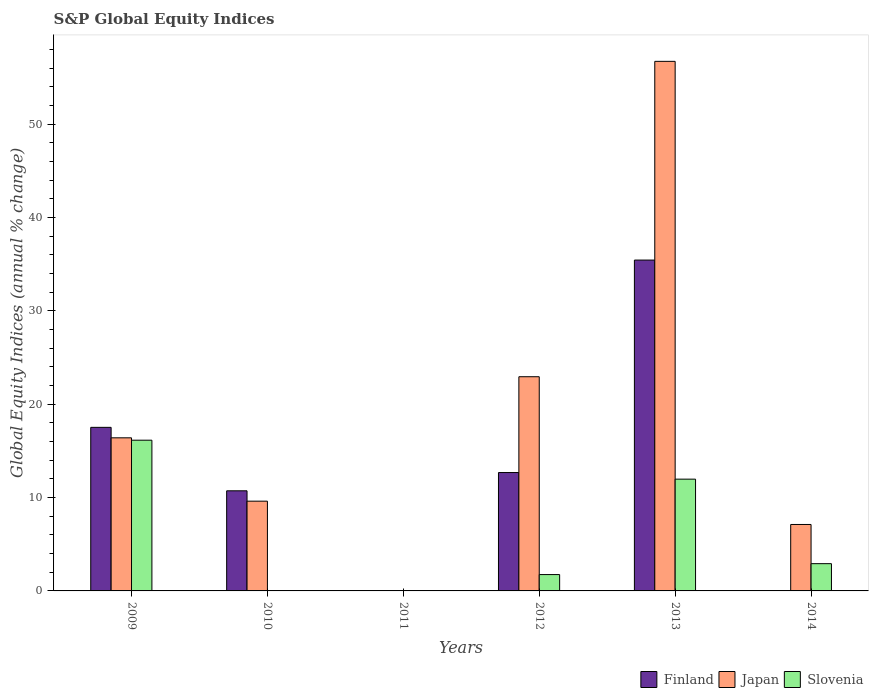Are the number of bars per tick equal to the number of legend labels?
Make the answer very short. No. How many bars are there on the 5th tick from the left?
Offer a very short reply. 3. What is the label of the 3rd group of bars from the left?
Keep it short and to the point. 2011. In how many cases, is the number of bars for a given year not equal to the number of legend labels?
Provide a succinct answer. 3. What is the global equity indices in Finland in 2013?
Provide a short and direct response. 35.44. Across all years, what is the maximum global equity indices in Slovenia?
Your answer should be compact. 16.14. Across all years, what is the minimum global equity indices in Finland?
Your response must be concise. 0. In which year was the global equity indices in Finland maximum?
Your answer should be compact. 2013. What is the total global equity indices in Slovenia in the graph?
Offer a very short reply. 32.79. What is the difference between the global equity indices in Slovenia in 2012 and that in 2014?
Provide a short and direct response. -1.17. What is the difference between the global equity indices in Japan in 2010 and the global equity indices in Finland in 2012?
Your answer should be compact. -3.06. What is the average global equity indices in Finland per year?
Offer a very short reply. 12.73. In the year 2012, what is the difference between the global equity indices in Japan and global equity indices in Slovenia?
Keep it short and to the point. 21.19. What is the ratio of the global equity indices in Slovenia in 2012 to that in 2014?
Give a very brief answer. 0.6. Is the difference between the global equity indices in Japan in 2009 and 2012 greater than the difference between the global equity indices in Slovenia in 2009 and 2012?
Provide a short and direct response. No. What is the difference between the highest and the second highest global equity indices in Slovenia?
Keep it short and to the point. 4.17. What is the difference between the highest and the lowest global equity indices in Finland?
Ensure brevity in your answer.  35.44. How many bars are there?
Ensure brevity in your answer.  13. Are all the bars in the graph horizontal?
Your response must be concise. No. How many years are there in the graph?
Your answer should be compact. 6. Are the values on the major ticks of Y-axis written in scientific E-notation?
Keep it short and to the point. No. Does the graph contain grids?
Provide a short and direct response. No. How many legend labels are there?
Your answer should be compact. 3. How are the legend labels stacked?
Offer a terse response. Horizontal. What is the title of the graph?
Your response must be concise. S&P Global Equity Indices. What is the label or title of the Y-axis?
Your answer should be compact. Global Equity Indices (annual % change). What is the Global Equity Indices (annual % change) of Finland in 2009?
Provide a succinct answer. 17.52. What is the Global Equity Indices (annual % change) in Japan in 2009?
Provide a succinct answer. 16.4. What is the Global Equity Indices (annual % change) in Slovenia in 2009?
Your answer should be very brief. 16.14. What is the Global Equity Indices (annual % change) of Finland in 2010?
Your answer should be compact. 10.72. What is the Global Equity Indices (annual % change) of Japan in 2010?
Provide a short and direct response. 9.61. What is the Global Equity Indices (annual % change) of Slovenia in 2010?
Keep it short and to the point. 0. What is the Global Equity Indices (annual % change) in Finland in 2011?
Your response must be concise. 0. What is the Global Equity Indices (annual % change) of Japan in 2011?
Make the answer very short. 0. What is the Global Equity Indices (annual % change) of Slovenia in 2011?
Your answer should be very brief. 0. What is the Global Equity Indices (annual % change) of Finland in 2012?
Offer a terse response. 12.68. What is the Global Equity Indices (annual % change) in Japan in 2012?
Your answer should be very brief. 22.94. What is the Global Equity Indices (annual % change) of Slovenia in 2012?
Make the answer very short. 1.75. What is the Global Equity Indices (annual % change) of Finland in 2013?
Give a very brief answer. 35.44. What is the Global Equity Indices (annual % change) of Japan in 2013?
Provide a succinct answer. 56.72. What is the Global Equity Indices (annual % change) of Slovenia in 2013?
Give a very brief answer. 11.97. What is the Global Equity Indices (annual % change) in Finland in 2014?
Provide a succinct answer. 0. What is the Global Equity Indices (annual % change) of Japan in 2014?
Provide a succinct answer. 7.12. What is the Global Equity Indices (annual % change) in Slovenia in 2014?
Your answer should be very brief. 2.92. Across all years, what is the maximum Global Equity Indices (annual % change) in Finland?
Keep it short and to the point. 35.44. Across all years, what is the maximum Global Equity Indices (annual % change) in Japan?
Your response must be concise. 56.72. Across all years, what is the maximum Global Equity Indices (annual % change) in Slovenia?
Your answer should be very brief. 16.14. Across all years, what is the minimum Global Equity Indices (annual % change) in Finland?
Make the answer very short. 0. What is the total Global Equity Indices (annual % change) of Finland in the graph?
Your answer should be very brief. 76.36. What is the total Global Equity Indices (annual % change) of Japan in the graph?
Keep it short and to the point. 112.79. What is the total Global Equity Indices (annual % change) in Slovenia in the graph?
Provide a succinct answer. 32.79. What is the difference between the Global Equity Indices (annual % change) of Finland in 2009 and that in 2010?
Give a very brief answer. 6.8. What is the difference between the Global Equity Indices (annual % change) in Japan in 2009 and that in 2010?
Make the answer very short. 6.78. What is the difference between the Global Equity Indices (annual % change) of Finland in 2009 and that in 2012?
Ensure brevity in your answer.  4.84. What is the difference between the Global Equity Indices (annual % change) in Japan in 2009 and that in 2012?
Make the answer very short. -6.54. What is the difference between the Global Equity Indices (annual % change) of Slovenia in 2009 and that in 2012?
Your response must be concise. 14.39. What is the difference between the Global Equity Indices (annual % change) in Finland in 2009 and that in 2013?
Your response must be concise. -17.92. What is the difference between the Global Equity Indices (annual % change) of Japan in 2009 and that in 2013?
Make the answer very short. -40.32. What is the difference between the Global Equity Indices (annual % change) in Slovenia in 2009 and that in 2013?
Offer a terse response. 4.17. What is the difference between the Global Equity Indices (annual % change) of Japan in 2009 and that in 2014?
Offer a terse response. 9.28. What is the difference between the Global Equity Indices (annual % change) of Slovenia in 2009 and that in 2014?
Your answer should be compact. 13.22. What is the difference between the Global Equity Indices (annual % change) of Finland in 2010 and that in 2012?
Make the answer very short. -1.96. What is the difference between the Global Equity Indices (annual % change) of Japan in 2010 and that in 2012?
Give a very brief answer. -13.33. What is the difference between the Global Equity Indices (annual % change) of Finland in 2010 and that in 2013?
Offer a terse response. -24.71. What is the difference between the Global Equity Indices (annual % change) in Japan in 2010 and that in 2013?
Your answer should be compact. -47.11. What is the difference between the Global Equity Indices (annual % change) in Japan in 2010 and that in 2014?
Give a very brief answer. 2.5. What is the difference between the Global Equity Indices (annual % change) of Finland in 2012 and that in 2013?
Give a very brief answer. -22.76. What is the difference between the Global Equity Indices (annual % change) in Japan in 2012 and that in 2013?
Ensure brevity in your answer.  -33.78. What is the difference between the Global Equity Indices (annual % change) of Slovenia in 2012 and that in 2013?
Ensure brevity in your answer.  -10.22. What is the difference between the Global Equity Indices (annual % change) of Japan in 2012 and that in 2014?
Offer a terse response. 15.82. What is the difference between the Global Equity Indices (annual % change) of Slovenia in 2012 and that in 2014?
Offer a terse response. -1.17. What is the difference between the Global Equity Indices (annual % change) in Japan in 2013 and that in 2014?
Provide a short and direct response. 49.6. What is the difference between the Global Equity Indices (annual % change) of Slovenia in 2013 and that in 2014?
Offer a terse response. 9.05. What is the difference between the Global Equity Indices (annual % change) in Finland in 2009 and the Global Equity Indices (annual % change) in Japan in 2010?
Make the answer very short. 7.91. What is the difference between the Global Equity Indices (annual % change) in Finland in 2009 and the Global Equity Indices (annual % change) in Japan in 2012?
Ensure brevity in your answer.  -5.42. What is the difference between the Global Equity Indices (annual % change) of Finland in 2009 and the Global Equity Indices (annual % change) of Slovenia in 2012?
Offer a terse response. 15.77. What is the difference between the Global Equity Indices (annual % change) in Japan in 2009 and the Global Equity Indices (annual % change) in Slovenia in 2012?
Keep it short and to the point. 14.65. What is the difference between the Global Equity Indices (annual % change) in Finland in 2009 and the Global Equity Indices (annual % change) in Japan in 2013?
Ensure brevity in your answer.  -39.2. What is the difference between the Global Equity Indices (annual % change) in Finland in 2009 and the Global Equity Indices (annual % change) in Slovenia in 2013?
Keep it short and to the point. 5.55. What is the difference between the Global Equity Indices (annual % change) of Japan in 2009 and the Global Equity Indices (annual % change) of Slovenia in 2013?
Make the answer very short. 4.43. What is the difference between the Global Equity Indices (annual % change) in Finland in 2009 and the Global Equity Indices (annual % change) in Japan in 2014?
Provide a succinct answer. 10.4. What is the difference between the Global Equity Indices (annual % change) of Finland in 2009 and the Global Equity Indices (annual % change) of Slovenia in 2014?
Your answer should be very brief. 14.6. What is the difference between the Global Equity Indices (annual % change) in Japan in 2009 and the Global Equity Indices (annual % change) in Slovenia in 2014?
Ensure brevity in your answer.  13.48. What is the difference between the Global Equity Indices (annual % change) of Finland in 2010 and the Global Equity Indices (annual % change) of Japan in 2012?
Your answer should be compact. -12.22. What is the difference between the Global Equity Indices (annual % change) in Finland in 2010 and the Global Equity Indices (annual % change) in Slovenia in 2012?
Make the answer very short. 8.97. What is the difference between the Global Equity Indices (annual % change) of Japan in 2010 and the Global Equity Indices (annual % change) of Slovenia in 2012?
Ensure brevity in your answer.  7.86. What is the difference between the Global Equity Indices (annual % change) of Finland in 2010 and the Global Equity Indices (annual % change) of Japan in 2013?
Your answer should be very brief. -46. What is the difference between the Global Equity Indices (annual % change) in Finland in 2010 and the Global Equity Indices (annual % change) in Slovenia in 2013?
Provide a succinct answer. -1.25. What is the difference between the Global Equity Indices (annual % change) of Japan in 2010 and the Global Equity Indices (annual % change) of Slovenia in 2013?
Offer a terse response. -2.36. What is the difference between the Global Equity Indices (annual % change) in Finland in 2010 and the Global Equity Indices (annual % change) in Japan in 2014?
Ensure brevity in your answer.  3.61. What is the difference between the Global Equity Indices (annual % change) in Finland in 2010 and the Global Equity Indices (annual % change) in Slovenia in 2014?
Keep it short and to the point. 7.8. What is the difference between the Global Equity Indices (annual % change) of Japan in 2010 and the Global Equity Indices (annual % change) of Slovenia in 2014?
Offer a very short reply. 6.7. What is the difference between the Global Equity Indices (annual % change) of Finland in 2012 and the Global Equity Indices (annual % change) of Japan in 2013?
Provide a short and direct response. -44.04. What is the difference between the Global Equity Indices (annual % change) of Finland in 2012 and the Global Equity Indices (annual % change) of Slovenia in 2013?
Make the answer very short. 0.71. What is the difference between the Global Equity Indices (annual % change) in Japan in 2012 and the Global Equity Indices (annual % change) in Slovenia in 2013?
Ensure brevity in your answer.  10.97. What is the difference between the Global Equity Indices (annual % change) in Finland in 2012 and the Global Equity Indices (annual % change) in Japan in 2014?
Make the answer very short. 5.56. What is the difference between the Global Equity Indices (annual % change) of Finland in 2012 and the Global Equity Indices (annual % change) of Slovenia in 2014?
Give a very brief answer. 9.76. What is the difference between the Global Equity Indices (annual % change) in Japan in 2012 and the Global Equity Indices (annual % change) in Slovenia in 2014?
Ensure brevity in your answer.  20.02. What is the difference between the Global Equity Indices (annual % change) in Finland in 2013 and the Global Equity Indices (annual % change) in Japan in 2014?
Your response must be concise. 28.32. What is the difference between the Global Equity Indices (annual % change) in Finland in 2013 and the Global Equity Indices (annual % change) in Slovenia in 2014?
Provide a short and direct response. 32.52. What is the difference between the Global Equity Indices (annual % change) in Japan in 2013 and the Global Equity Indices (annual % change) in Slovenia in 2014?
Your response must be concise. 53.8. What is the average Global Equity Indices (annual % change) of Finland per year?
Keep it short and to the point. 12.73. What is the average Global Equity Indices (annual % change) in Japan per year?
Ensure brevity in your answer.  18.8. What is the average Global Equity Indices (annual % change) of Slovenia per year?
Provide a short and direct response. 5.46. In the year 2009, what is the difference between the Global Equity Indices (annual % change) of Finland and Global Equity Indices (annual % change) of Japan?
Provide a succinct answer. 1.12. In the year 2009, what is the difference between the Global Equity Indices (annual % change) of Finland and Global Equity Indices (annual % change) of Slovenia?
Offer a very short reply. 1.38. In the year 2009, what is the difference between the Global Equity Indices (annual % change) in Japan and Global Equity Indices (annual % change) in Slovenia?
Offer a terse response. 0.26. In the year 2010, what is the difference between the Global Equity Indices (annual % change) in Finland and Global Equity Indices (annual % change) in Japan?
Keep it short and to the point. 1.11. In the year 2012, what is the difference between the Global Equity Indices (annual % change) of Finland and Global Equity Indices (annual % change) of Japan?
Provide a succinct answer. -10.26. In the year 2012, what is the difference between the Global Equity Indices (annual % change) in Finland and Global Equity Indices (annual % change) in Slovenia?
Your response must be concise. 10.93. In the year 2012, what is the difference between the Global Equity Indices (annual % change) in Japan and Global Equity Indices (annual % change) in Slovenia?
Your answer should be compact. 21.19. In the year 2013, what is the difference between the Global Equity Indices (annual % change) in Finland and Global Equity Indices (annual % change) in Japan?
Ensure brevity in your answer.  -21.28. In the year 2013, what is the difference between the Global Equity Indices (annual % change) of Finland and Global Equity Indices (annual % change) of Slovenia?
Provide a succinct answer. 23.46. In the year 2013, what is the difference between the Global Equity Indices (annual % change) in Japan and Global Equity Indices (annual % change) in Slovenia?
Offer a very short reply. 44.75. In the year 2014, what is the difference between the Global Equity Indices (annual % change) of Japan and Global Equity Indices (annual % change) of Slovenia?
Ensure brevity in your answer.  4.2. What is the ratio of the Global Equity Indices (annual % change) of Finland in 2009 to that in 2010?
Provide a short and direct response. 1.63. What is the ratio of the Global Equity Indices (annual % change) in Japan in 2009 to that in 2010?
Provide a short and direct response. 1.71. What is the ratio of the Global Equity Indices (annual % change) of Finland in 2009 to that in 2012?
Your answer should be compact. 1.38. What is the ratio of the Global Equity Indices (annual % change) in Japan in 2009 to that in 2012?
Your answer should be compact. 0.71. What is the ratio of the Global Equity Indices (annual % change) of Slovenia in 2009 to that in 2012?
Provide a short and direct response. 9.22. What is the ratio of the Global Equity Indices (annual % change) in Finland in 2009 to that in 2013?
Give a very brief answer. 0.49. What is the ratio of the Global Equity Indices (annual % change) in Japan in 2009 to that in 2013?
Provide a short and direct response. 0.29. What is the ratio of the Global Equity Indices (annual % change) in Slovenia in 2009 to that in 2013?
Your answer should be very brief. 1.35. What is the ratio of the Global Equity Indices (annual % change) of Japan in 2009 to that in 2014?
Make the answer very short. 2.3. What is the ratio of the Global Equity Indices (annual % change) of Slovenia in 2009 to that in 2014?
Offer a very short reply. 5.53. What is the ratio of the Global Equity Indices (annual % change) of Finland in 2010 to that in 2012?
Ensure brevity in your answer.  0.85. What is the ratio of the Global Equity Indices (annual % change) in Japan in 2010 to that in 2012?
Your response must be concise. 0.42. What is the ratio of the Global Equity Indices (annual % change) in Finland in 2010 to that in 2013?
Ensure brevity in your answer.  0.3. What is the ratio of the Global Equity Indices (annual % change) in Japan in 2010 to that in 2013?
Provide a succinct answer. 0.17. What is the ratio of the Global Equity Indices (annual % change) in Japan in 2010 to that in 2014?
Give a very brief answer. 1.35. What is the ratio of the Global Equity Indices (annual % change) of Finland in 2012 to that in 2013?
Offer a terse response. 0.36. What is the ratio of the Global Equity Indices (annual % change) in Japan in 2012 to that in 2013?
Offer a terse response. 0.4. What is the ratio of the Global Equity Indices (annual % change) in Slovenia in 2012 to that in 2013?
Offer a very short reply. 0.15. What is the ratio of the Global Equity Indices (annual % change) in Japan in 2012 to that in 2014?
Provide a succinct answer. 3.22. What is the ratio of the Global Equity Indices (annual % change) in Japan in 2013 to that in 2014?
Offer a very short reply. 7.97. What is the ratio of the Global Equity Indices (annual % change) in Slovenia in 2013 to that in 2014?
Make the answer very short. 4.1. What is the difference between the highest and the second highest Global Equity Indices (annual % change) of Finland?
Provide a succinct answer. 17.92. What is the difference between the highest and the second highest Global Equity Indices (annual % change) in Japan?
Your answer should be very brief. 33.78. What is the difference between the highest and the second highest Global Equity Indices (annual % change) in Slovenia?
Your response must be concise. 4.17. What is the difference between the highest and the lowest Global Equity Indices (annual % change) in Finland?
Your answer should be compact. 35.44. What is the difference between the highest and the lowest Global Equity Indices (annual % change) in Japan?
Offer a very short reply. 56.72. What is the difference between the highest and the lowest Global Equity Indices (annual % change) of Slovenia?
Your answer should be compact. 16.14. 